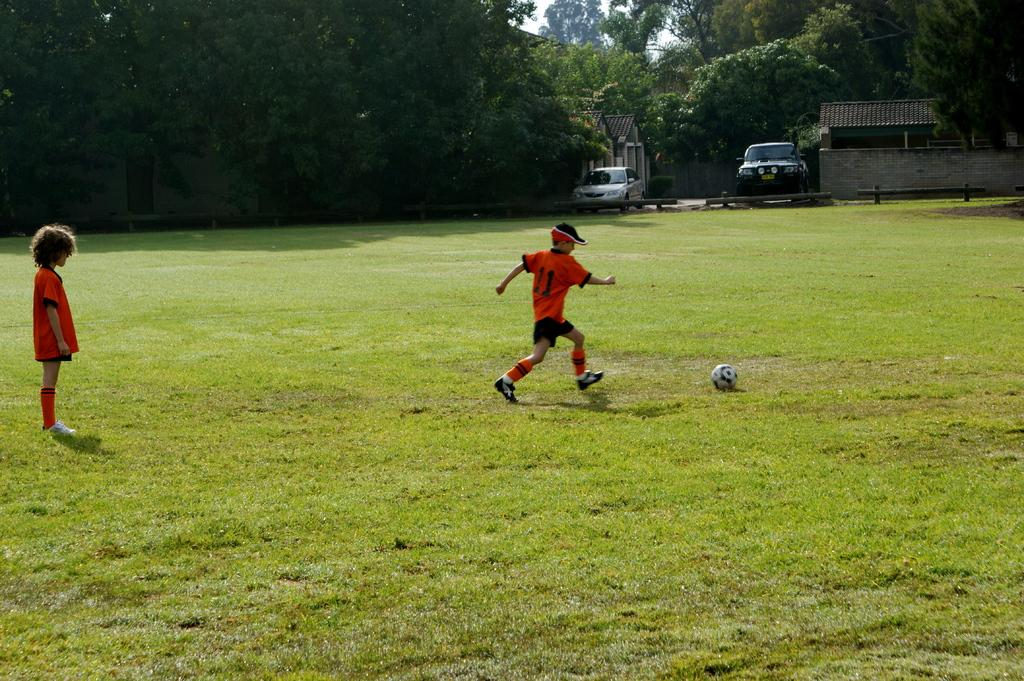How many children are in the image? There are two children in the image. What object can be seen with the children? There is a ball in the image. What type of surface is visible in the image? There is a ground in the image. What type of seating is present in the image? There are benches in the image. What type of vehicles are visible in the image? There are cars in the image. What type of buildings are visible in the image? There are houses in the image. What type of vegetation is visible in the image? There are trees in the image. What part of the natural environment is visible in the image? The sky is visible in the image. What degree does the kitten have in the image? There is no kitten present in the image, so it cannot have a degree. 